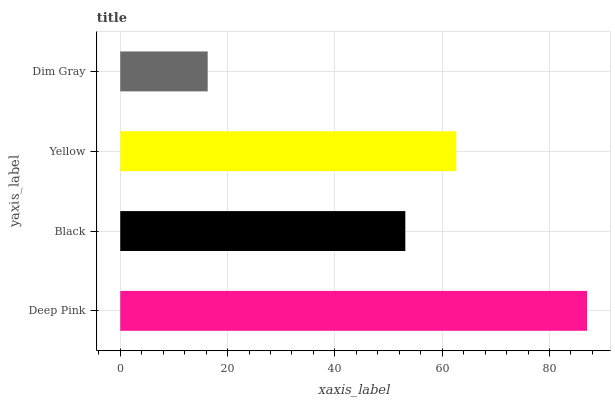Is Dim Gray the minimum?
Answer yes or no. Yes. Is Deep Pink the maximum?
Answer yes or no. Yes. Is Black the minimum?
Answer yes or no. No. Is Black the maximum?
Answer yes or no. No. Is Deep Pink greater than Black?
Answer yes or no. Yes. Is Black less than Deep Pink?
Answer yes or no. Yes. Is Black greater than Deep Pink?
Answer yes or no. No. Is Deep Pink less than Black?
Answer yes or no. No. Is Yellow the high median?
Answer yes or no. Yes. Is Black the low median?
Answer yes or no. Yes. Is Deep Pink the high median?
Answer yes or no. No. Is Yellow the low median?
Answer yes or no. No. 